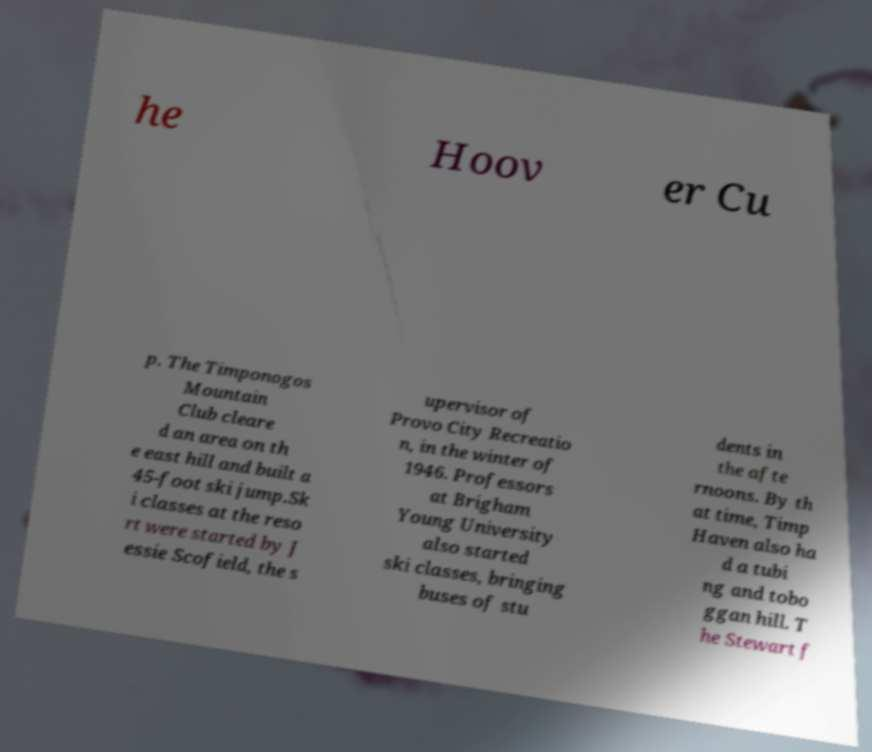Can you accurately transcribe the text from the provided image for me? he Hoov er Cu p. The Timponogos Mountain Club cleare d an area on th e east hill and built a 45-foot ski jump.Sk i classes at the reso rt were started by J essie Scofield, the s upervisor of Provo City Recreatio n, in the winter of 1946. Professors at Brigham Young University also started ski classes, bringing buses of stu dents in the afte rnoons. By th at time, Timp Haven also ha d a tubi ng and tobo ggan hill. T he Stewart f 